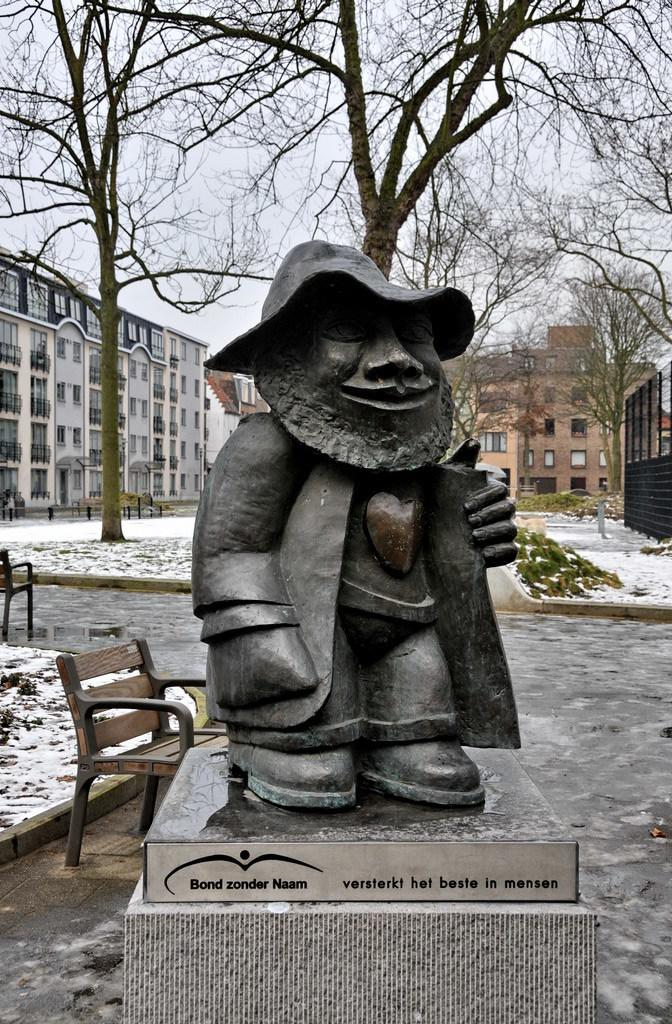What type of setting is depicted in the image? The image is an outside view. What is one of the main features in the image? There is a statue in the image. What is another object present in the image? There is a bench in the image. What can be seen in the distance in the image? There are buildings and trees in the background of the image. What color is the orange in the image? There is no orange present in the image. How many lights can be seen illuminating the statue in the image? There are no lights visible in the image; it is an outside view with natural lighting. 